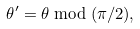Convert formula to latex. <formula><loc_0><loc_0><loc_500><loc_500>\theta ^ { \prime } = \theta \bmod ( \pi / 2 ) ,</formula> 